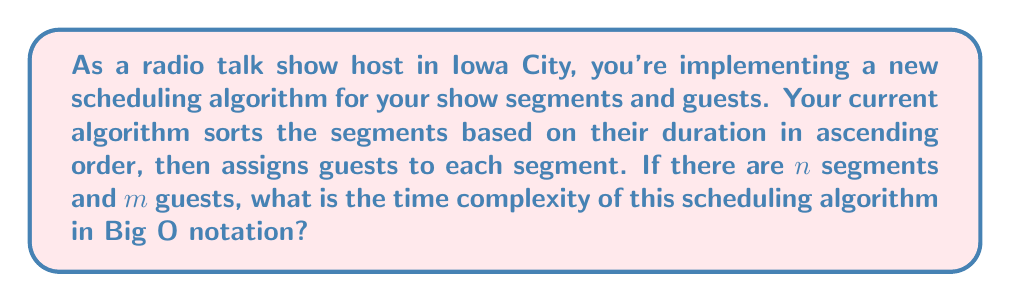Help me with this question. To analyze the time complexity of this scheduling algorithm, let's break it down into steps:

1. Sorting the segments:
   The algorithm first sorts the segments based on their duration. Assuming an efficient sorting algorithm like Merge Sort or Quick Sort is used, this step has a time complexity of $O(n \log n)$, where $n$ is the number of segments.

2. Assigning guests to segments:
   After sorting, the algorithm assigns guests to each segment. In the worst case, this involves comparing each guest with each segment. This step has a time complexity of $O(n \cdot m)$, where $n$ is the number of segments and $m$ is the number of guests.

The total time complexity is the sum of these two steps:

$$ T(n,m) = O(n \log n) + O(n \cdot m) $$

To determine the overall Big O notation, we need to consider the dominant term:

- If $m \leq \log n$, then $O(n \log n)$ dominates.
- If $m > \log n$, then $O(n \cdot m)$ dominates.

Since we don't have specific information about the relationship between $n$ and $m$, we should express the time complexity using both terms to cover all cases:

$$ O(n \log n + n \cdot m) $$

This notation accurately represents the algorithm's efficiency for all possible relationships between the number of segments and guests.
Answer: $O(n \log n + n \cdot m)$ 